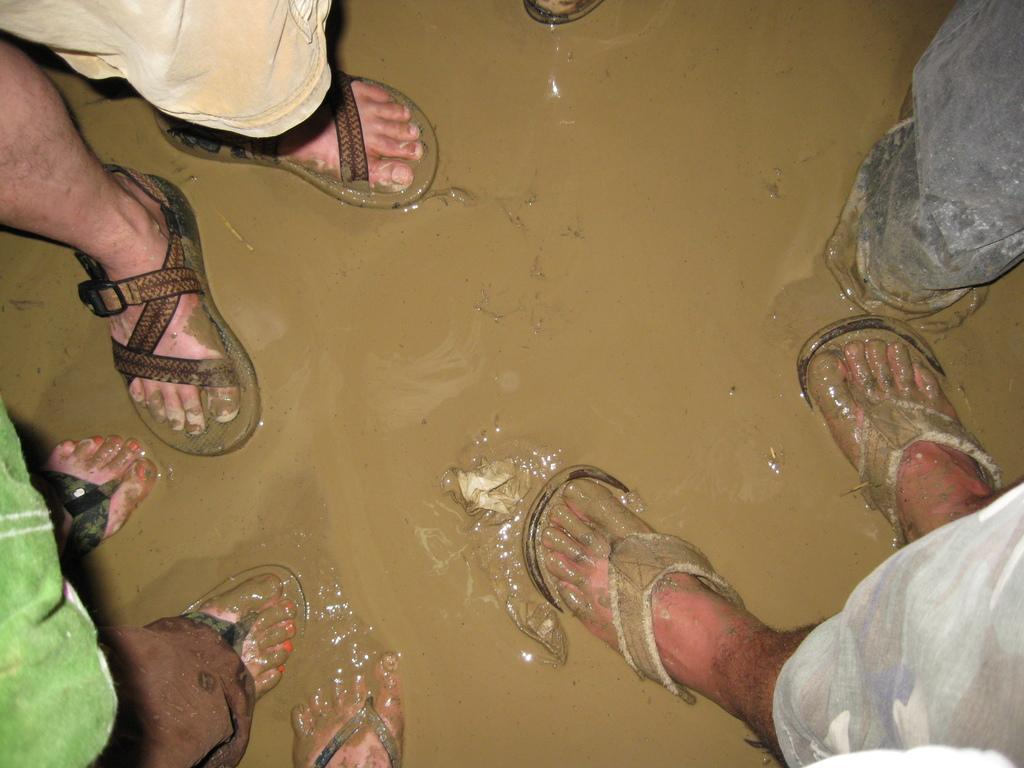What is the main subject of the image? The main subject of the image is a person holding a camera and a tripod. What is the person doing in the image? The person is holding a camera and a tripod, which suggests they might be taking a photograph. What can be seen in the background of the image? There is a building in the background. How many objects is the person holding in the image? The person is holding a camera and a tripod, which makes two objects. What type of advertisement can be seen on the button in the image? There is no button or advertisement present in the image. How many planes are visible in the image? There are no planes visible in the image. 